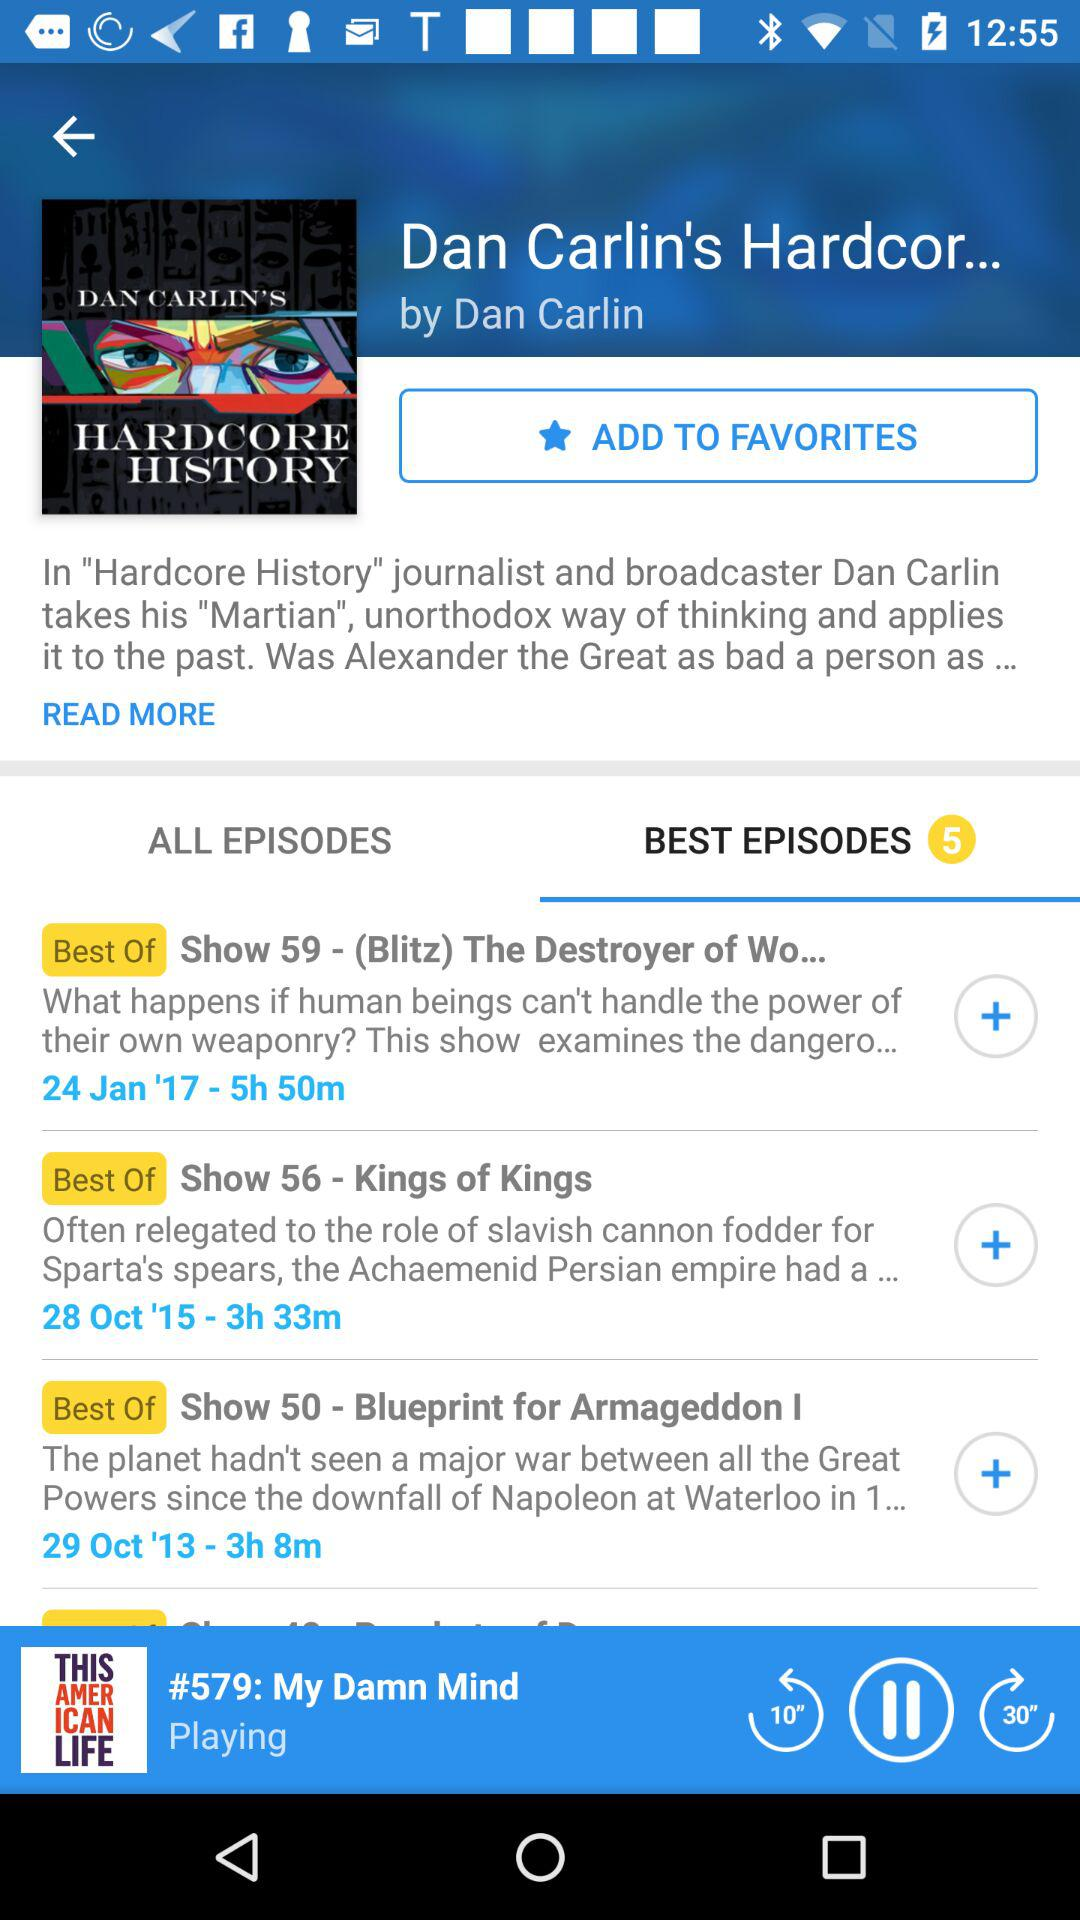Which song is playing? The song is playing "#579: My Damn Mind". 